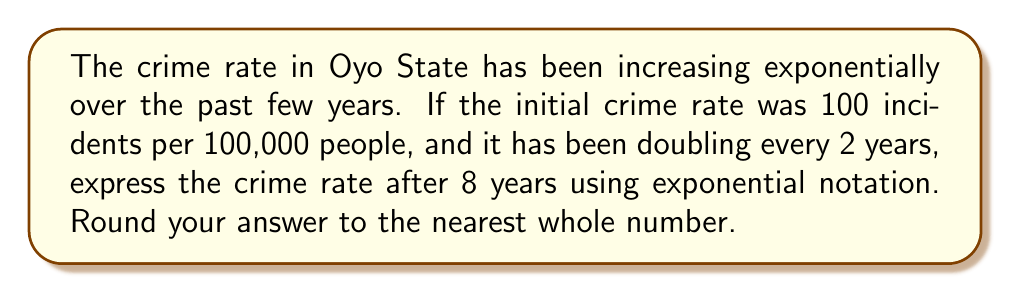Can you solve this math problem? Let's approach this step-by-step:

1) The initial crime rate is 100 incidents per 100,000 people.

2) The rate doubles every 2 years, which means:
   - After 2 years: $100 \times 2^1 = 200$
   - After 4 years: $100 \times 2^2 = 400$
   - After 6 years: $100 \times 2^3 = 800$
   - After 8 years: $100 \times 2^4 = 1600$

3) We can express this as an exponential function:
   $$ \text{Crime Rate} = 100 \times 2^{\frac{t}{2}} $$
   Where $t$ is the number of years.

4) For 8 years:
   $$ \text{Crime Rate} = 100 \times 2^{\frac{8}{2}} = 100 \times 2^4 = 100 \times 16 = 1600 $$

5) To express this in exponential notation:
   $$ 1600 = 1.6 \times 10^3 $$

Therefore, after 8 years, the crime rate would be approximately $1.6 \times 10^3$ incidents per 100,000 people.
Answer: $1.6 \times 10^3$ incidents per 100,000 people 